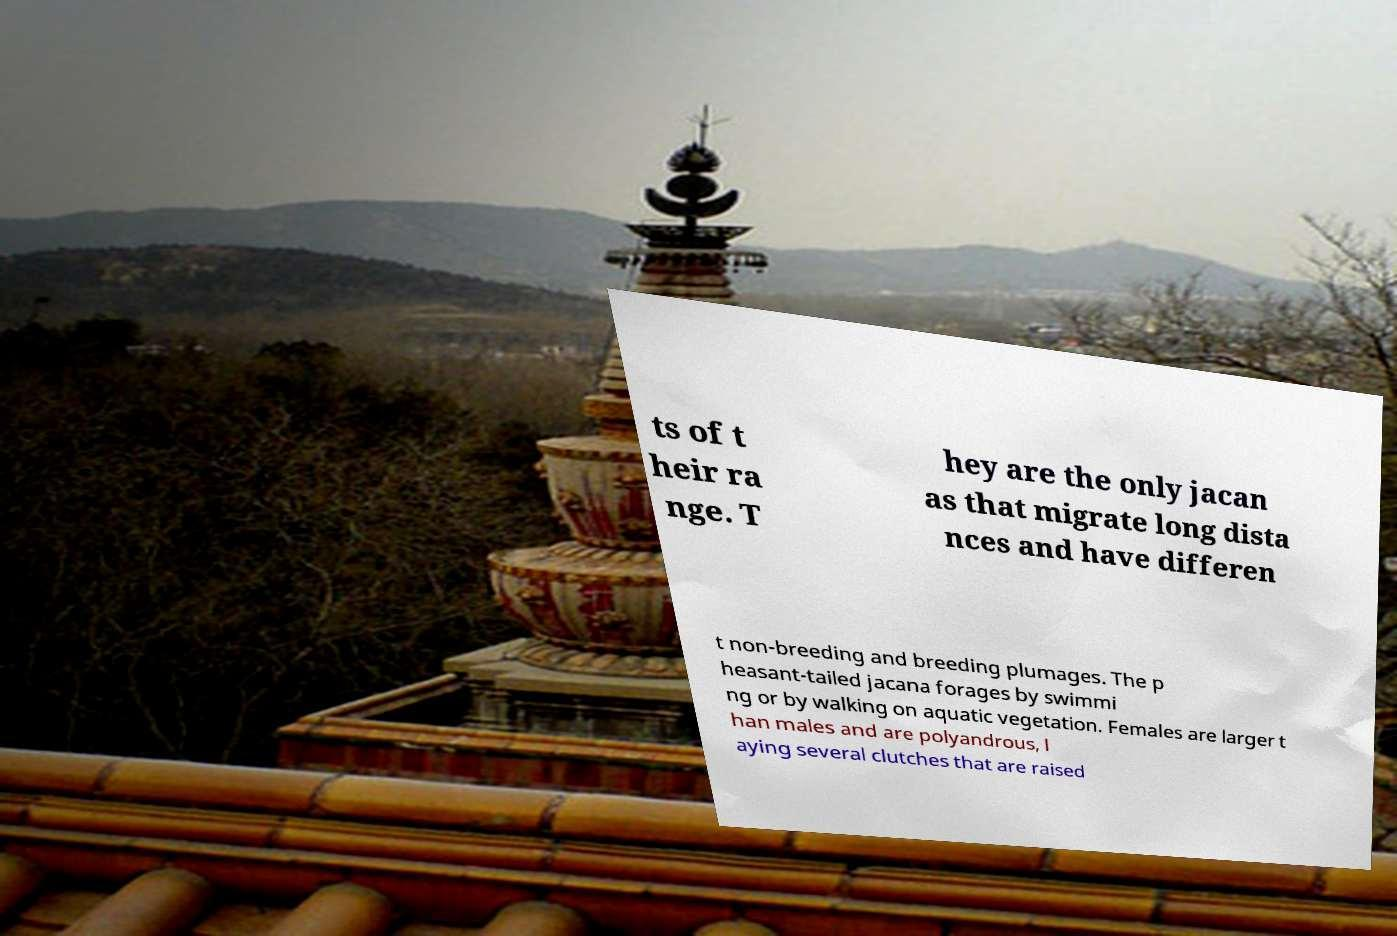Please identify and transcribe the text found in this image. ts of t heir ra nge. T hey are the only jacan as that migrate long dista nces and have differen t non-breeding and breeding plumages. The p heasant-tailed jacana forages by swimmi ng or by walking on aquatic vegetation. Females are larger t han males and are polyandrous, l aying several clutches that are raised 